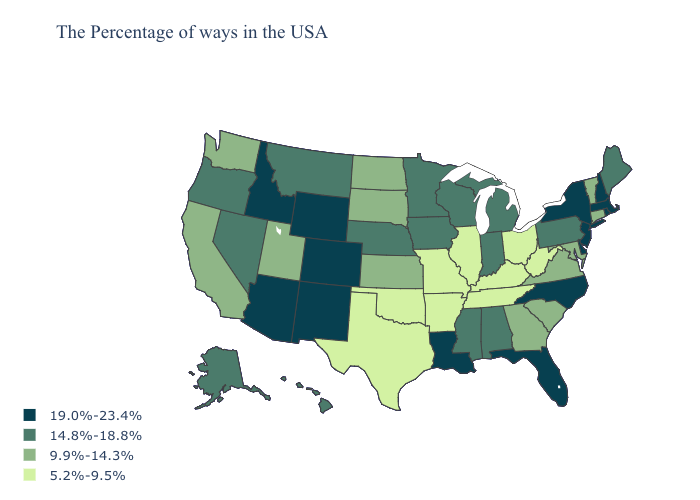Name the states that have a value in the range 19.0%-23.4%?
Write a very short answer. Massachusetts, Rhode Island, New Hampshire, New York, New Jersey, Delaware, North Carolina, Florida, Louisiana, Wyoming, Colorado, New Mexico, Arizona, Idaho. Which states have the lowest value in the Northeast?
Quick response, please. Vermont, Connecticut. Does Hawaii have the lowest value in the USA?
Give a very brief answer. No. What is the highest value in the USA?
Answer briefly. 19.0%-23.4%. Which states hav the highest value in the West?
Keep it brief. Wyoming, Colorado, New Mexico, Arizona, Idaho. Among the states that border New York , which have the highest value?
Be succinct. Massachusetts, New Jersey. Name the states that have a value in the range 19.0%-23.4%?
Give a very brief answer. Massachusetts, Rhode Island, New Hampshire, New York, New Jersey, Delaware, North Carolina, Florida, Louisiana, Wyoming, Colorado, New Mexico, Arizona, Idaho. What is the value of South Carolina?
Quick response, please. 9.9%-14.3%. What is the value of Nebraska?
Concise answer only. 14.8%-18.8%. Name the states that have a value in the range 19.0%-23.4%?
Quick response, please. Massachusetts, Rhode Island, New Hampshire, New York, New Jersey, Delaware, North Carolina, Florida, Louisiana, Wyoming, Colorado, New Mexico, Arizona, Idaho. What is the value of Nevada?
Concise answer only. 14.8%-18.8%. Which states hav the highest value in the MidWest?
Concise answer only. Michigan, Indiana, Wisconsin, Minnesota, Iowa, Nebraska. What is the lowest value in states that border Wisconsin?
Be succinct. 5.2%-9.5%. Does the map have missing data?
Short answer required. No. Name the states that have a value in the range 5.2%-9.5%?
Quick response, please. West Virginia, Ohio, Kentucky, Tennessee, Illinois, Missouri, Arkansas, Oklahoma, Texas. 